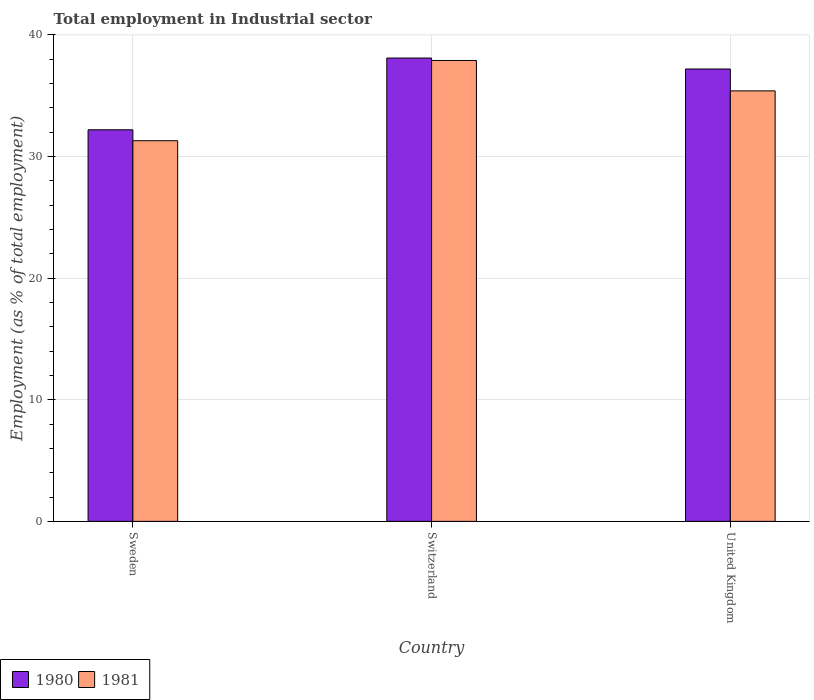Are the number of bars per tick equal to the number of legend labels?
Make the answer very short. Yes. How many bars are there on the 1st tick from the left?
Provide a short and direct response. 2. What is the label of the 1st group of bars from the left?
Your answer should be compact. Sweden. In how many cases, is the number of bars for a given country not equal to the number of legend labels?
Offer a very short reply. 0. What is the employment in industrial sector in 1981 in Sweden?
Offer a very short reply. 31.3. Across all countries, what is the maximum employment in industrial sector in 1980?
Your response must be concise. 38.1. Across all countries, what is the minimum employment in industrial sector in 1981?
Keep it short and to the point. 31.3. In which country was the employment in industrial sector in 1980 maximum?
Give a very brief answer. Switzerland. What is the total employment in industrial sector in 1980 in the graph?
Your answer should be very brief. 107.5. What is the difference between the employment in industrial sector in 1981 in Sweden and that in United Kingdom?
Provide a short and direct response. -4.1. What is the difference between the employment in industrial sector in 1980 in Switzerland and the employment in industrial sector in 1981 in United Kingdom?
Your response must be concise. 2.7. What is the average employment in industrial sector in 1980 per country?
Give a very brief answer. 35.83. What is the difference between the employment in industrial sector of/in 1980 and employment in industrial sector of/in 1981 in Sweden?
Offer a terse response. 0.9. In how many countries, is the employment in industrial sector in 1981 greater than 36 %?
Keep it short and to the point. 1. What is the ratio of the employment in industrial sector in 1981 in Sweden to that in United Kingdom?
Your answer should be compact. 0.88. Is the difference between the employment in industrial sector in 1980 in Sweden and Switzerland greater than the difference between the employment in industrial sector in 1981 in Sweden and Switzerland?
Give a very brief answer. Yes. What is the difference between the highest and the lowest employment in industrial sector in 1980?
Make the answer very short. 5.9. Is the sum of the employment in industrial sector in 1981 in Switzerland and United Kingdom greater than the maximum employment in industrial sector in 1980 across all countries?
Give a very brief answer. Yes. What does the 2nd bar from the right in Sweden represents?
Your response must be concise. 1980. How many bars are there?
Your response must be concise. 6. How many countries are there in the graph?
Your response must be concise. 3. What is the difference between two consecutive major ticks on the Y-axis?
Offer a terse response. 10. Does the graph contain grids?
Your answer should be very brief. Yes. Where does the legend appear in the graph?
Provide a short and direct response. Bottom left. How are the legend labels stacked?
Make the answer very short. Horizontal. What is the title of the graph?
Offer a terse response. Total employment in Industrial sector. What is the label or title of the X-axis?
Your answer should be very brief. Country. What is the label or title of the Y-axis?
Ensure brevity in your answer.  Employment (as % of total employment). What is the Employment (as % of total employment) in 1980 in Sweden?
Offer a very short reply. 32.2. What is the Employment (as % of total employment) of 1981 in Sweden?
Your answer should be very brief. 31.3. What is the Employment (as % of total employment) of 1980 in Switzerland?
Your answer should be very brief. 38.1. What is the Employment (as % of total employment) in 1981 in Switzerland?
Offer a terse response. 37.9. What is the Employment (as % of total employment) of 1980 in United Kingdom?
Give a very brief answer. 37.2. What is the Employment (as % of total employment) in 1981 in United Kingdom?
Give a very brief answer. 35.4. Across all countries, what is the maximum Employment (as % of total employment) in 1980?
Your answer should be very brief. 38.1. Across all countries, what is the maximum Employment (as % of total employment) in 1981?
Provide a short and direct response. 37.9. Across all countries, what is the minimum Employment (as % of total employment) of 1980?
Give a very brief answer. 32.2. Across all countries, what is the minimum Employment (as % of total employment) in 1981?
Offer a terse response. 31.3. What is the total Employment (as % of total employment) of 1980 in the graph?
Ensure brevity in your answer.  107.5. What is the total Employment (as % of total employment) of 1981 in the graph?
Your response must be concise. 104.6. What is the difference between the Employment (as % of total employment) in 1981 in Sweden and that in Switzerland?
Offer a very short reply. -6.6. What is the difference between the Employment (as % of total employment) of 1980 in Sweden and that in United Kingdom?
Make the answer very short. -5. What is the difference between the Employment (as % of total employment) of 1980 in Switzerland and that in United Kingdom?
Offer a terse response. 0.9. What is the difference between the Employment (as % of total employment) of 1981 in Switzerland and that in United Kingdom?
Keep it short and to the point. 2.5. What is the difference between the Employment (as % of total employment) in 1980 in Sweden and the Employment (as % of total employment) in 1981 in Switzerland?
Your response must be concise. -5.7. What is the difference between the Employment (as % of total employment) of 1980 in Sweden and the Employment (as % of total employment) of 1981 in United Kingdom?
Keep it short and to the point. -3.2. What is the average Employment (as % of total employment) in 1980 per country?
Offer a terse response. 35.83. What is the average Employment (as % of total employment) of 1981 per country?
Your response must be concise. 34.87. What is the difference between the Employment (as % of total employment) in 1980 and Employment (as % of total employment) in 1981 in United Kingdom?
Your answer should be compact. 1.8. What is the ratio of the Employment (as % of total employment) of 1980 in Sweden to that in Switzerland?
Your answer should be very brief. 0.85. What is the ratio of the Employment (as % of total employment) in 1981 in Sweden to that in Switzerland?
Your answer should be very brief. 0.83. What is the ratio of the Employment (as % of total employment) in 1980 in Sweden to that in United Kingdom?
Ensure brevity in your answer.  0.87. What is the ratio of the Employment (as % of total employment) of 1981 in Sweden to that in United Kingdom?
Provide a short and direct response. 0.88. What is the ratio of the Employment (as % of total employment) of 1980 in Switzerland to that in United Kingdom?
Provide a succinct answer. 1.02. What is the ratio of the Employment (as % of total employment) in 1981 in Switzerland to that in United Kingdom?
Make the answer very short. 1.07. What is the difference between the highest and the second highest Employment (as % of total employment) of 1980?
Make the answer very short. 0.9. What is the difference between the highest and the lowest Employment (as % of total employment) in 1980?
Keep it short and to the point. 5.9. What is the difference between the highest and the lowest Employment (as % of total employment) in 1981?
Keep it short and to the point. 6.6. 